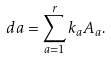Convert formula to latex. <formula><loc_0><loc_0><loc_500><loc_500>d a = \sum _ { a = 1 } ^ { r } k _ { a } A _ { a } .</formula> 